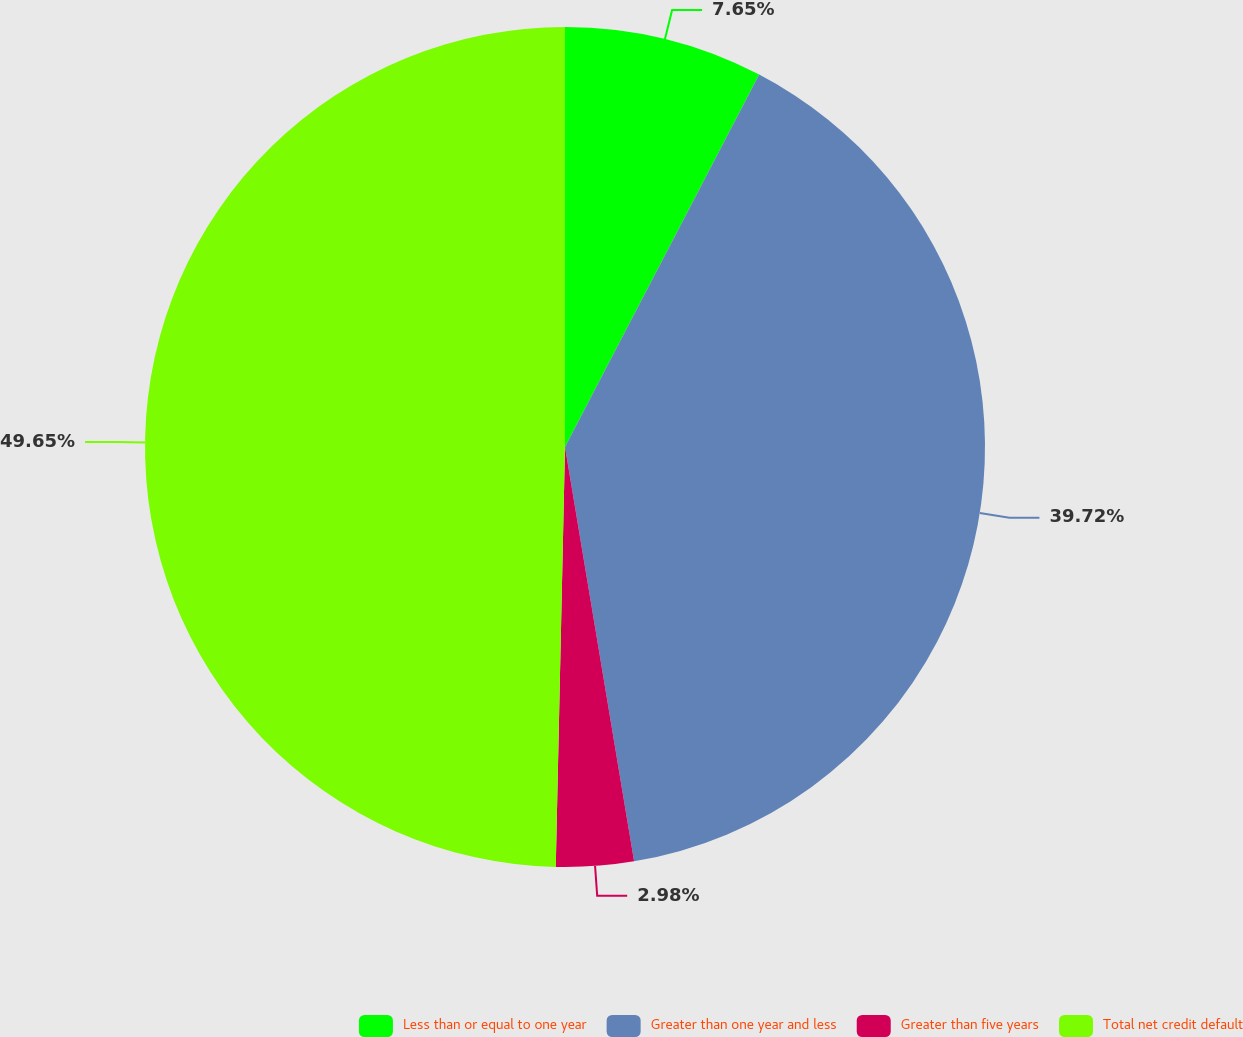<chart> <loc_0><loc_0><loc_500><loc_500><pie_chart><fcel>Less than or equal to one year<fcel>Greater than one year and less<fcel>Greater than five years<fcel>Total net credit default<nl><fcel>7.65%<fcel>39.72%<fcel>2.98%<fcel>49.65%<nl></chart> 